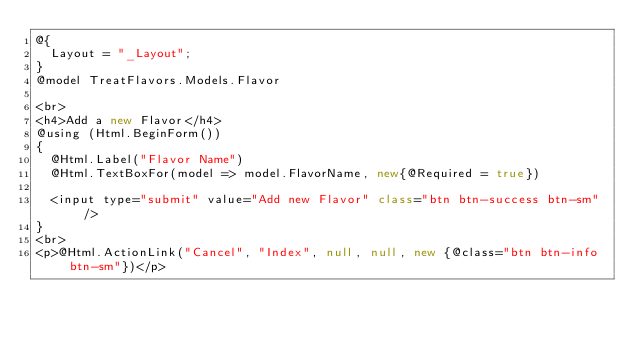<code> <loc_0><loc_0><loc_500><loc_500><_C#_>@{
  Layout = "_Layout";
}
@model TreatFlavors.Models.Flavor

<br>
<h4>Add a new Flavor</h4>
@using (Html.BeginForm())
{
  @Html.Label("Flavor Name")
  @Html.TextBoxFor(model => model.FlavorName, new{@Required = true})

  <input type="submit" value="Add new Flavor" class="btn btn-success btn-sm" />
}
<br>
<p>@Html.ActionLink("Cancel", "Index", null, null, new {@class="btn btn-info btn-sm"})</p></code> 